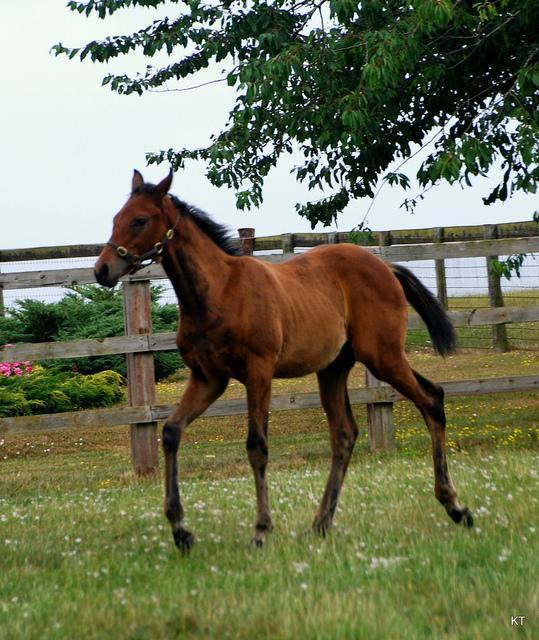How many horses are visible?
Give a very brief answer. 1. 